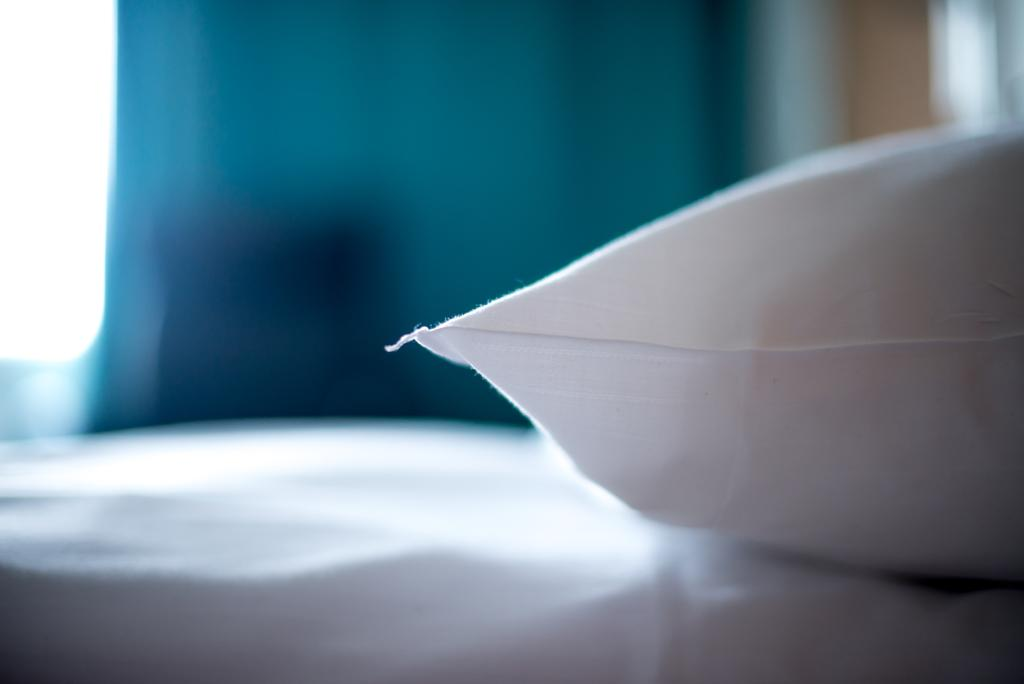What piece of furniture is present in the image? There is a bed in the image. What is placed on the bed? There is a pillow on the bed. What color is the pillow? The pillow is white. Can you describe the background of the image? The background of the image is blurred. Is there a goat playing volleyball with a knot in the image? No, there is no goat or volleyball present in the image. 